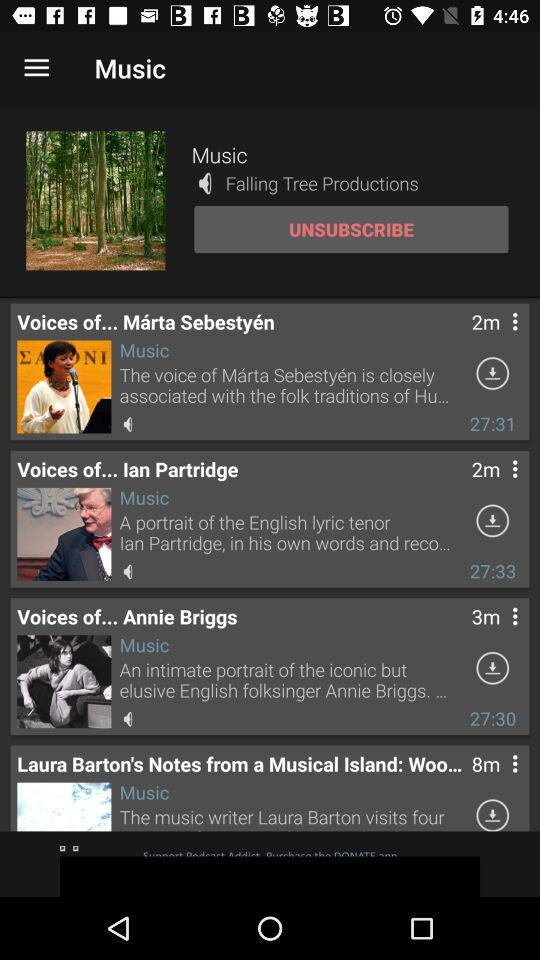What is the duration of the voice of Ian Partridge? The duration of the voice of Ian Partridge is 27:33. 